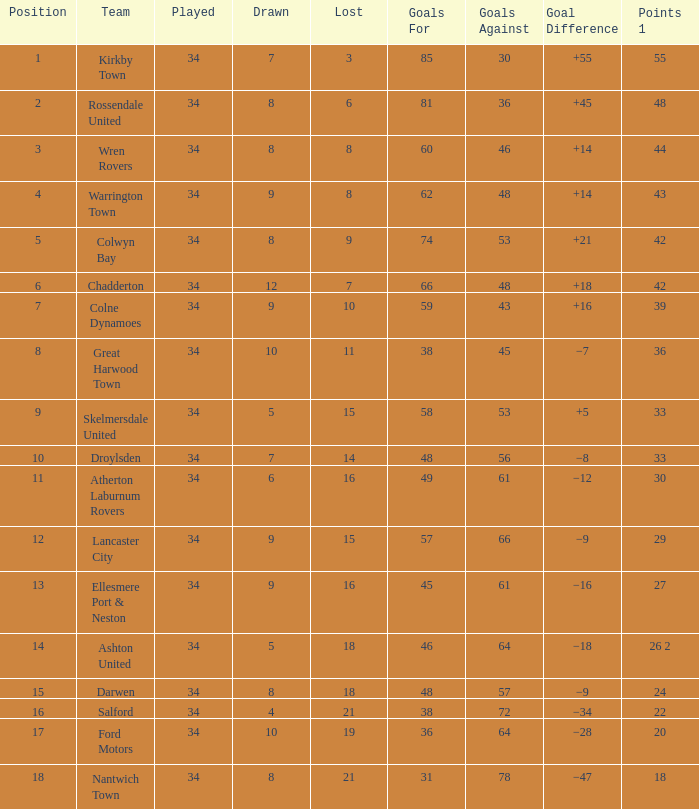What is the aggregate number of goals when the draw is below 7, less than 21 games are lost, and there are 1 in 33 points? 1.0. 